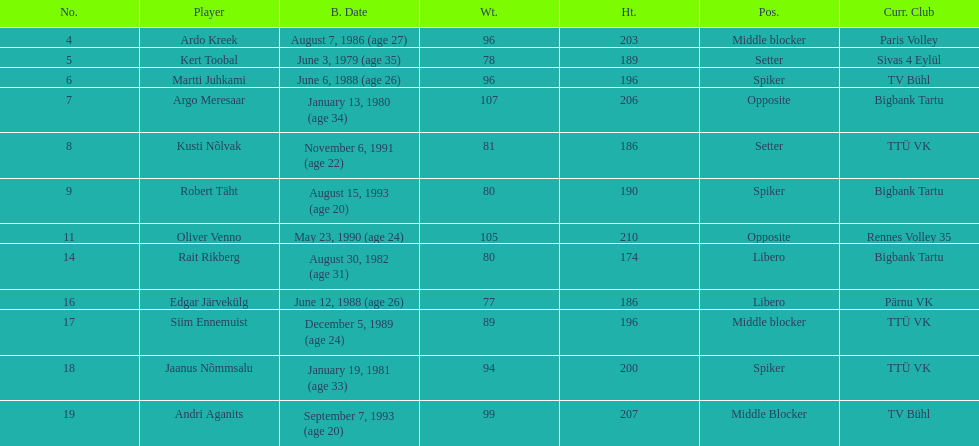How many players are middle blockers? 3. 